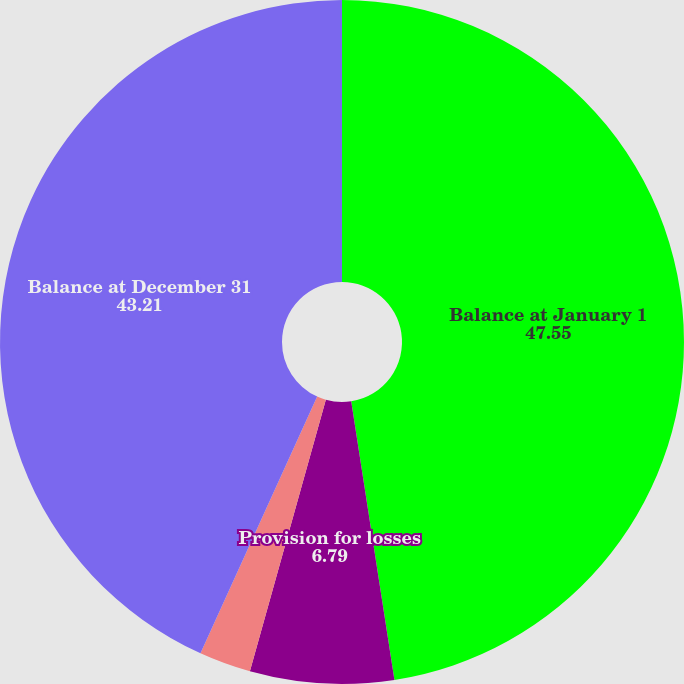Convert chart. <chart><loc_0><loc_0><loc_500><loc_500><pie_chart><fcel>Balance at January 1<fcel>Provision for losses<fcel>Currency translation and other<fcel>Balance at December 31<nl><fcel>47.55%<fcel>6.79%<fcel>2.45%<fcel>43.21%<nl></chart> 